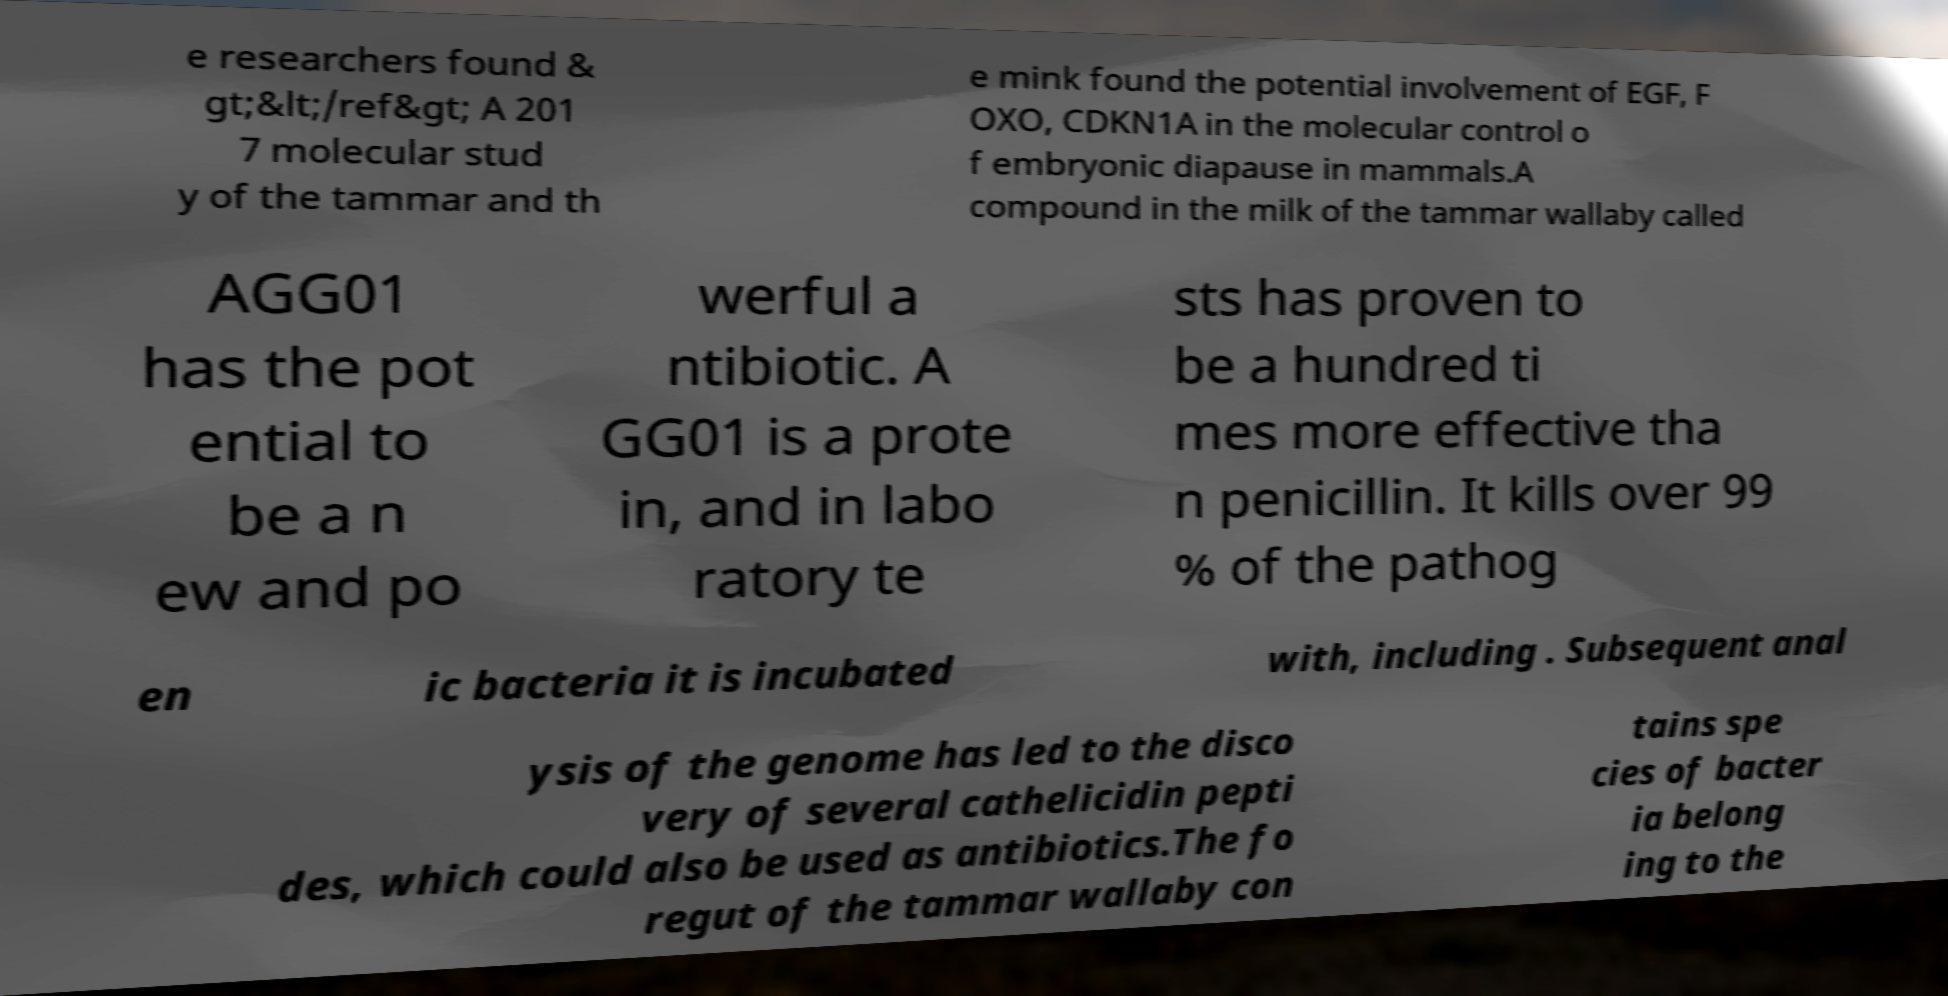I need the written content from this picture converted into text. Can you do that? e researchers found & gt;&lt;/ref&gt; A 201 7 molecular stud y of the tammar and th e mink found the potential involvement of EGF, F OXO, CDKN1A in the molecular control o f embryonic diapause in mammals.A compound in the milk of the tammar wallaby called AGG01 has the pot ential to be a n ew and po werful a ntibiotic. A GG01 is a prote in, and in labo ratory te sts has proven to be a hundred ti mes more effective tha n penicillin. It kills over 99 % of the pathog en ic bacteria it is incubated with, including . Subsequent anal ysis of the genome has led to the disco very of several cathelicidin pepti des, which could also be used as antibiotics.The fo regut of the tammar wallaby con tains spe cies of bacter ia belong ing to the 